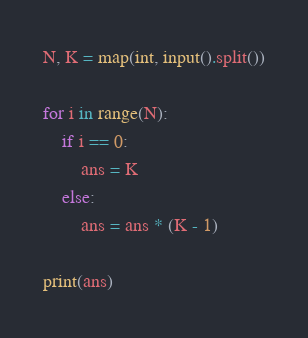<code> <loc_0><loc_0><loc_500><loc_500><_Python_>N, K = map(int, input().split())

for i in range(N):
    if i == 0:
        ans = K
    else:
        ans = ans * (K - 1)

print(ans)</code> 